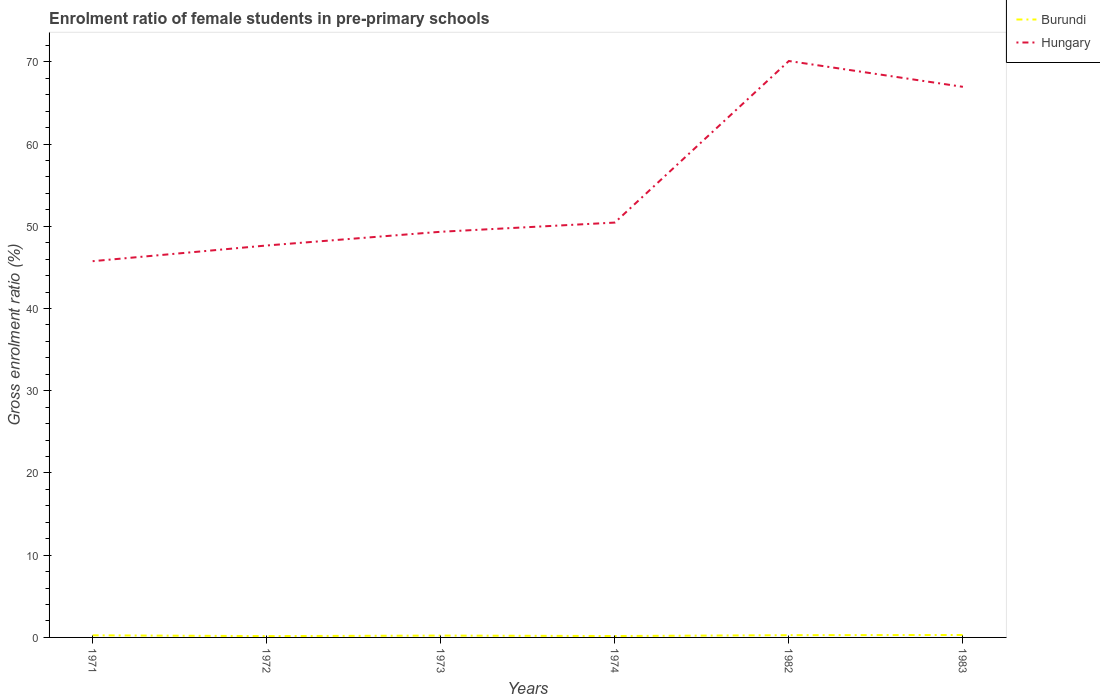Does the line corresponding to Burundi intersect with the line corresponding to Hungary?
Your answer should be very brief. No. Across all years, what is the maximum enrolment ratio of female students in pre-primary schools in Burundi?
Provide a short and direct response. 0.16. In which year was the enrolment ratio of female students in pre-primary schools in Hungary maximum?
Your answer should be very brief. 1971. What is the total enrolment ratio of female students in pre-primary schools in Hungary in the graph?
Ensure brevity in your answer.  -16.51. What is the difference between the highest and the second highest enrolment ratio of female students in pre-primary schools in Hungary?
Provide a short and direct response. 24.35. What is the difference between the highest and the lowest enrolment ratio of female students in pre-primary schools in Hungary?
Your answer should be compact. 2. Is the enrolment ratio of female students in pre-primary schools in Hungary strictly greater than the enrolment ratio of female students in pre-primary schools in Burundi over the years?
Your answer should be compact. No. How many years are there in the graph?
Your response must be concise. 6. What is the difference between two consecutive major ticks on the Y-axis?
Your answer should be compact. 10. Does the graph contain any zero values?
Make the answer very short. No. How are the legend labels stacked?
Your response must be concise. Vertical. What is the title of the graph?
Make the answer very short. Enrolment ratio of female students in pre-primary schools. Does "Sub-Saharan Africa (developing only)" appear as one of the legend labels in the graph?
Give a very brief answer. No. What is the label or title of the X-axis?
Your response must be concise. Years. What is the label or title of the Y-axis?
Your response must be concise. Gross enrolment ratio (%). What is the Gross enrolment ratio (%) of Burundi in 1971?
Provide a short and direct response. 0.26. What is the Gross enrolment ratio (%) in Hungary in 1971?
Your response must be concise. 45.76. What is the Gross enrolment ratio (%) of Burundi in 1972?
Your response must be concise. 0.16. What is the Gross enrolment ratio (%) in Hungary in 1972?
Keep it short and to the point. 47.67. What is the Gross enrolment ratio (%) of Burundi in 1973?
Ensure brevity in your answer.  0.23. What is the Gross enrolment ratio (%) in Hungary in 1973?
Ensure brevity in your answer.  49.34. What is the Gross enrolment ratio (%) in Burundi in 1974?
Provide a short and direct response. 0.17. What is the Gross enrolment ratio (%) of Hungary in 1974?
Your answer should be very brief. 50.45. What is the Gross enrolment ratio (%) in Burundi in 1982?
Keep it short and to the point. 0.27. What is the Gross enrolment ratio (%) of Hungary in 1982?
Your response must be concise. 70.1. What is the Gross enrolment ratio (%) of Burundi in 1983?
Make the answer very short. 0.3. What is the Gross enrolment ratio (%) in Hungary in 1983?
Your response must be concise. 66.96. Across all years, what is the maximum Gross enrolment ratio (%) of Burundi?
Provide a short and direct response. 0.3. Across all years, what is the maximum Gross enrolment ratio (%) in Hungary?
Make the answer very short. 70.1. Across all years, what is the minimum Gross enrolment ratio (%) of Burundi?
Your answer should be very brief. 0.16. Across all years, what is the minimum Gross enrolment ratio (%) of Hungary?
Keep it short and to the point. 45.76. What is the total Gross enrolment ratio (%) of Burundi in the graph?
Provide a short and direct response. 1.39. What is the total Gross enrolment ratio (%) of Hungary in the graph?
Provide a succinct answer. 330.28. What is the difference between the Gross enrolment ratio (%) of Burundi in 1971 and that in 1972?
Offer a very short reply. 0.09. What is the difference between the Gross enrolment ratio (%) of Hungary in 1971 and that in 1972?
Provide a succinct answer. -1.91. What is the difference between the Gross enrolment ratio (%) in Burundi in 1971 and that in 1973?
Ensure brevity in your answer.  0.03. What is the difference between the Gross enrolment ratio (%) in Hungary in 1971 and that in 1973?
Keep it short and to the point. -3.58. What is the difference between the Gross enrolment ratio (%) of Burundi in 1971 and that in 1974?
Your answer should be very brief. 0.08. What is the difference between the Gross enrolment ratio (%) of Hungary in 1971 and that in 1974?
Ensure brevity in your answer.  -4.7. What is the difference between the Gross enrolment ratio (%) of Burundi in 1971 and that in 1982?
Ensure brevity in your answer.  -0.02. What is the difference between the Gross enrolment ratio (%) of Hungary in 1971 and that in 1982?
Provide a succinct answer. -24.35. What is the difference between the Gross enrolment ratio (%) in Burundi in 1971 and that in 1983?
Give a very brief answer. -0.04. What is the difference between the Gross enrolment ratio (%) in Hungary in 1971 and that in 1983?
Give a very brief answer. -21.2. What is the difference between the Gross enrolment ratio (%) in Burundi in 1972 and that in 1973?
Keep it short and to the point. -0.06. What is the difference between the Gross enrolment ratio (%) in Hungary in 1972 and that in 1973?
Make the answer very short. -1.67. What is the difference between the Gross enrolment ratio (%) in Burundi in 1972 and that in 1974?
Offer a terse response. -0.01. What is the difference between the Gross enrolment ratio (%) of Hungary in 1972 and that in 1974?
Offer a very short reply. -2.79. What is the difference between the Gross enrolment ratio (%) in Burundi in 1972 and that in 1982?
Offer a very short reply. -0.11. What is the difference between the Gross enrolment ratio (%) in Hungary in 1972 and that in 1982?
Your answer should be very brief. -22.44. What is the difference between the Gross enrolment ratio (%) in Burundi in 1972 and that in 1983?
Keep it short and to the point. -0.13. What is the difference between the Gross enrolment ratio (%) of Hungary in 1972 and that in 1983?
Your answer should be very brief. -19.3. What is the difference between the Gross enrolment ratio (%) in Burundi in 1973 and that in 1974?
Keep it short and to the point. 0.05. What is the difference between the Gross enrolment ratio (%) in Hungary in 1973 and that in 1974?
Offer a very short reply. -1.12. What is the difference between the Gross enrolment ratio (%) of Burundi in 1973 and that in 1982?
Give a very brief answer. -0.05. What is the difference between the Gross enrolment ratio (%) in Hungary in 1973 and that in 1982?
Offer a very short reply. -20.77. What is the difference between the Gross enrolment ratio (%) of Burundi in 1973 and that in 1983?
Your answer should be compact. -0.07. What is the difference between the Gross enrolment ratio (%) of Hungary in 1973 and that in 1983?
Offer a very short reply. -17.63. What is the difference between the Gross enrolment ratio (%) in Burundi in 1974 and that in 1982?
Provide a short and direct response. -0.1. What is the difference between the Gross enrolment ratio (%) of Hungary in 1974 and that in 1982?
Your response must be concise. -19.65. What is the difference between the Gross enrolment ratio (%) of Burundi in 1974 and that in 1983?
Make the answer very short. -0.12. What is the difference between the Gross enrolment ratio (%) in Hungary in 1974 and that in 1983?
Your answer should be very brief. -16.51. What is the difference between the Gross enrolment ratio (%) of Burundi in 1982 and that in 1983?
Keep it short and to the point. -0.02. What is the difference between the Gross enrolment ratio (%) of Hungary in 1982 and that in 1983?
Ensure brevity in your answer.  3.14. What is the difference between the Gross enrolment ratio (%) in Burundi in 1971 and the Gross enrolment ratio (%) in Hungary in 1972?
Your answer should be compact. -47.41. What is the difference between the Gross enrolment ratio (%) of Burundi in 1971 and the Gross enrolment ratio (%) of Hungary in 1973?
Your answer should be compact. -49.08. What is the difference between the Gross enrolment ratio (%) of Burundi in 1971 and the Gross enrolment ratio (%) of Hungary in 1974?
Offer a terse response. -50.2. What is the difference between the Gross enrolment ratio (%) of Burundi in 1971 and the Gross enrolment ratio (%) of Hungary in 1982?
Give a very brief answer. -69.85. What is the difference between the Gross enrolment ratio (%) of Burundi in 1971 and the Gross enrolment ratio (%) of Hungary in 1983?
Ensure brevity in your answer.  -66.71. What is the difference between the Gross enrolment ratio (%) in Burundi in 1972 and the Gross enrolment ratio (%) in Hungary in 1973?
Ensure brevity in your answer.  -49.17. What is the difference between the Gross enrolment ratio (%) in Burundi in 1972 and the Gross enrolment ratio (%) in Hungary in 1974?
Provide a succinct answer. -50.29. What is the difference between the Gross enrolment ratio (%) in Burundi in 1972 and the Gross enrolment ratio (%) in Hungary in 1982?
Keep it short and to the point. -69.94. What is the difference between the Gross enrolment ratio (%) in Burundi in 1972 and the Gross enrolment ratio (%) in Hungary in 1983?
Your answer should be very brief. -66.8. What is the difference between the Gross enrolment ratio (%) in Burundi in 1973 and the Gross enrolment ratio (%) in Hungary in 1974?
Offer a terse response. -50.23. What is the difference between the Gross enrolment ratio (%) in Burundi in 1973 and the Gross enrolment ratio (%) in Hungary in 1982?
Make the answer very short. -69.88. What is the difference between the Gross enrolment ratio (%) in Burundi in 1973 and the Gross enrolment ratio (%) in Hungary in 1983?
Give a very brief answer. -66.74. What is the difference between the Gross enrolment ratio (%) of Burundi in 1974 and the Gross enrolment ratio (%) of Hungary in 1982?
Keep it short and to the point. -69.93. What is the difference between the Gross enrolment ratio (%) in Burundi in 1974 and the Gross enrolment ratio (%) in Hungary in 1983?
Make the answer very short. -66.79. What is the difference between the Gross enrolment ratio (%) in Burundi in 1982 and the Gross enrolment ratio (%) in Hungary in 1983?
Your answer should be very brief. -66.69. What is the average Gross enrolment ratio (%) of Burundi per year?
Offer a very short reply. 0.23. What is the average Gross enrolment ratio (%) in Hungary per year?
Give a very brief answer. 55.05. In the year 1971, what is the difference between the Gross enrolment ratio (%) in Burundi and Gross enrolment ratio (%) in Hungary?
Give a very brief answer. -45.5. In the year 1972, what is the difference between the Gross enrolment ratio (%) of Burundi and Gross enrolment ratio (%) of Hungary?
Your answer should be very brief. -47.51. In the year 1973, what is the difference between the Gross enrolment ratio (%) of Burundi and Gross enrolment ratio (%) of Hungary?
Offer a very short reply. -49.11. In the year 1974, what is the difference between the Gross enrolment ratio (%) of Burundi and Gross enrolment ratio (%) of Hungary?
Provide a short and direct response. -50.28. In the year 1982, what is the difference between the Gross enrolment ratio (%) in Burundi and Gross enrolment ratio (%) in Hungary?
Give a very brief answer. -69.83. In the year 1983, what is the difference between the Gross enrolment ratio (%) of Burundi and Gross enrolment ratio (%) of Hungary?
Ensure brevity in your answer.  -66.67. What is the ratio of the Gross enrolment ratio (%) in Burundi in 1971 to that in 1972?
Keep it short and to the point. 1.58. What is the ratio of the Gross enrolment ratio (%) in Hungary in 1971 to that in 1972?
Provide a short and direct response. 0.96. What is the ratio of the Gross enrolment ratio (%) of Burundi in 1971 to that in 1973?
Your answer should be very brief. 1.14. What is the ratio of the Gross enrolment ratio (%) in Hungary in 1971 to that in 1973?
Your response must be concise. 0.93. What is the ratio of the Gross enrolment ratio (%) in Burundi in 1971 to that in 1974?
Your answer should be very brief. 1.49. What is the ratio of the Gross enrolment ratio (%) in Hungary in 1971 to that in 1974?
Ensure brevity in your answer.  0.91. What is the ratio of the Gross enrolment ratio (%) in Burundi in 1971 to that in 1982?
Your answer should be very brief. 0.94. What is the ratio of the Gross enrolment ratio (%) in Hungary in 1971 to that in 1982?
Your answer should be very brief. 0.65. What is the ratio of the Gross enrolment ratio (%) in Burundi in 1971 to that in 1983?
Your answer should be compact. 0.86. What is the ratio of the Gross enrolment ratio (%) of Hungary in 1971 to that in 1983?
Your answer should be very brief. 0.68. What is the ratio of the Gross enrolment ratio (%) of Burundi in 1972 to that in 1973?
Your answer should be very brief. 0.72. What is the ratio of the Gross enrolment ratio (%) in Hungary in 1972 to that in 1973?
Provide a short and direct response. 0.97. What is the ratio of the Gross enrolment ratio (%) in Burundi in 1972 to that in 1974?
Ensure brevity in your answer.  0.94. What is the ratio of the Gross enrolment ratio (%) in Hungary in 1972 to that in 1974?
Ensure brevity in your answer.  0.94. What is the ratio of the Gross enrolment ratio (%) in Burundi in 1972 to that in 1982?
Your response must be concise. 0.59. What is the ratio of the Gross enrolment ratio (%) of Hungary in 1972 to that in 1982?
Provide a succinct answer. 0.68. What is the ratio of the Gross enrolment ratio (%) in Burundi in 1972 to that in 1983?
Make the answer very short. 0.55. What is the ratio of the Gross enrolment ratio (%) in Hungary in 1972 to that in 1983?
Your response must be concise. 0.71. What is the ratio of the Gross enrolment ratio (%) of Burundi in 1973 to that in 1974?
Ensure brevity in your answer.  1.31. What is the ratio of the Gross enrolment ratio (%) of Hungary in 1973 to that in 1974?
Your answer should be very brief. 0.98. What is the ratio of the Gross enrolment ratio (%) in Burundi in 1973 to that in 1982?
Your answer should be compact. 0.82. What is the ratio of the Gross enrolment ratio (%) in Hungary in 1973 to that in 1982?
Keep it short and to the point. 0.7. What is the ratio of the Gross enrolment ratio (%) of Burundi in 1973 to that in 1983?
Provide a succinct answer. 0.76. What is the ratio of the Gross enrolment ratio (%) in Hungary in 1973 to that in 1983?
Keep it short and to the point. 0.74. What is the ratio of the Gross enrolment ratio (%) of Burundi in 1974 to that in 1982?
Offer a terse response. 0.63. What is the ratio of the Gross enrolment ratio (%) in Hungary in 1974 to that in 1982?
Offer a very short reply. 0.72. What is the ratio of the Gross enrolment ratio (%) of Burundi in 1974 to that in 1983?
Provide a short and direct response. 0.58. What is the ratio of the Gross enrolment ratio (%) of Hungary in 1974 to that in 1983?
Make the answer very short. 0.75. What is the ratio of the Gross enrolment ratio (%) in Burundi in 1982 to that in 1983?
Your answer should be very brief. 0.92. What is the ratio of the Gross enrolment ratio (%) in Hungary in 1982 to that in 1983?
Ensure brevity in your answer.  1.05. What is the difference between the highest and the second highest Gross enrolment ratio (%) of Burundi?
Make the answer very short. 0.02. What is the difference between the highest and the second highest Gross enrolment ratio (%) in Hungary?
Provide a succinct answer. 3.14. What is the difference between the highest and the lowest Gross enrolment ratio (%) of Burundi?
Your answer should be compact. 0.13. What is the difference between the highest and the lowest Gross enrolment ratio (%) of Hungary?
Offer a very short reply. 24.35. 